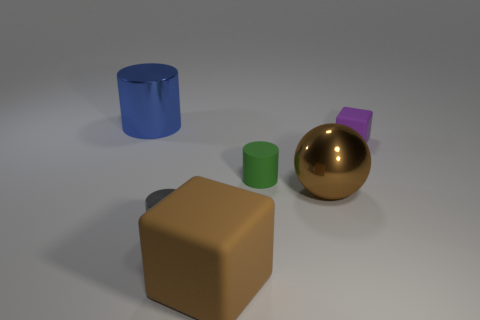Subtract all tiny gray cylinders. How many cylinders are left? 2 Add 3 big yellow metallic things. How many objects exist? 9 Subtract all blocks. How many objects are left? 4 Subtract 1 purple cubes. How many objects are left? 5 Subtract all brown blocks. Subtract all brown spheres. How many blocks are left? 1 Subtract all big yellow things. Subtract all big blue cylinders. How many objects are left? 5 Add 4 brown metal objects. How many brown metal objects are left? 5 Add 4 small blue objects. How many small blue objects exist? 4 